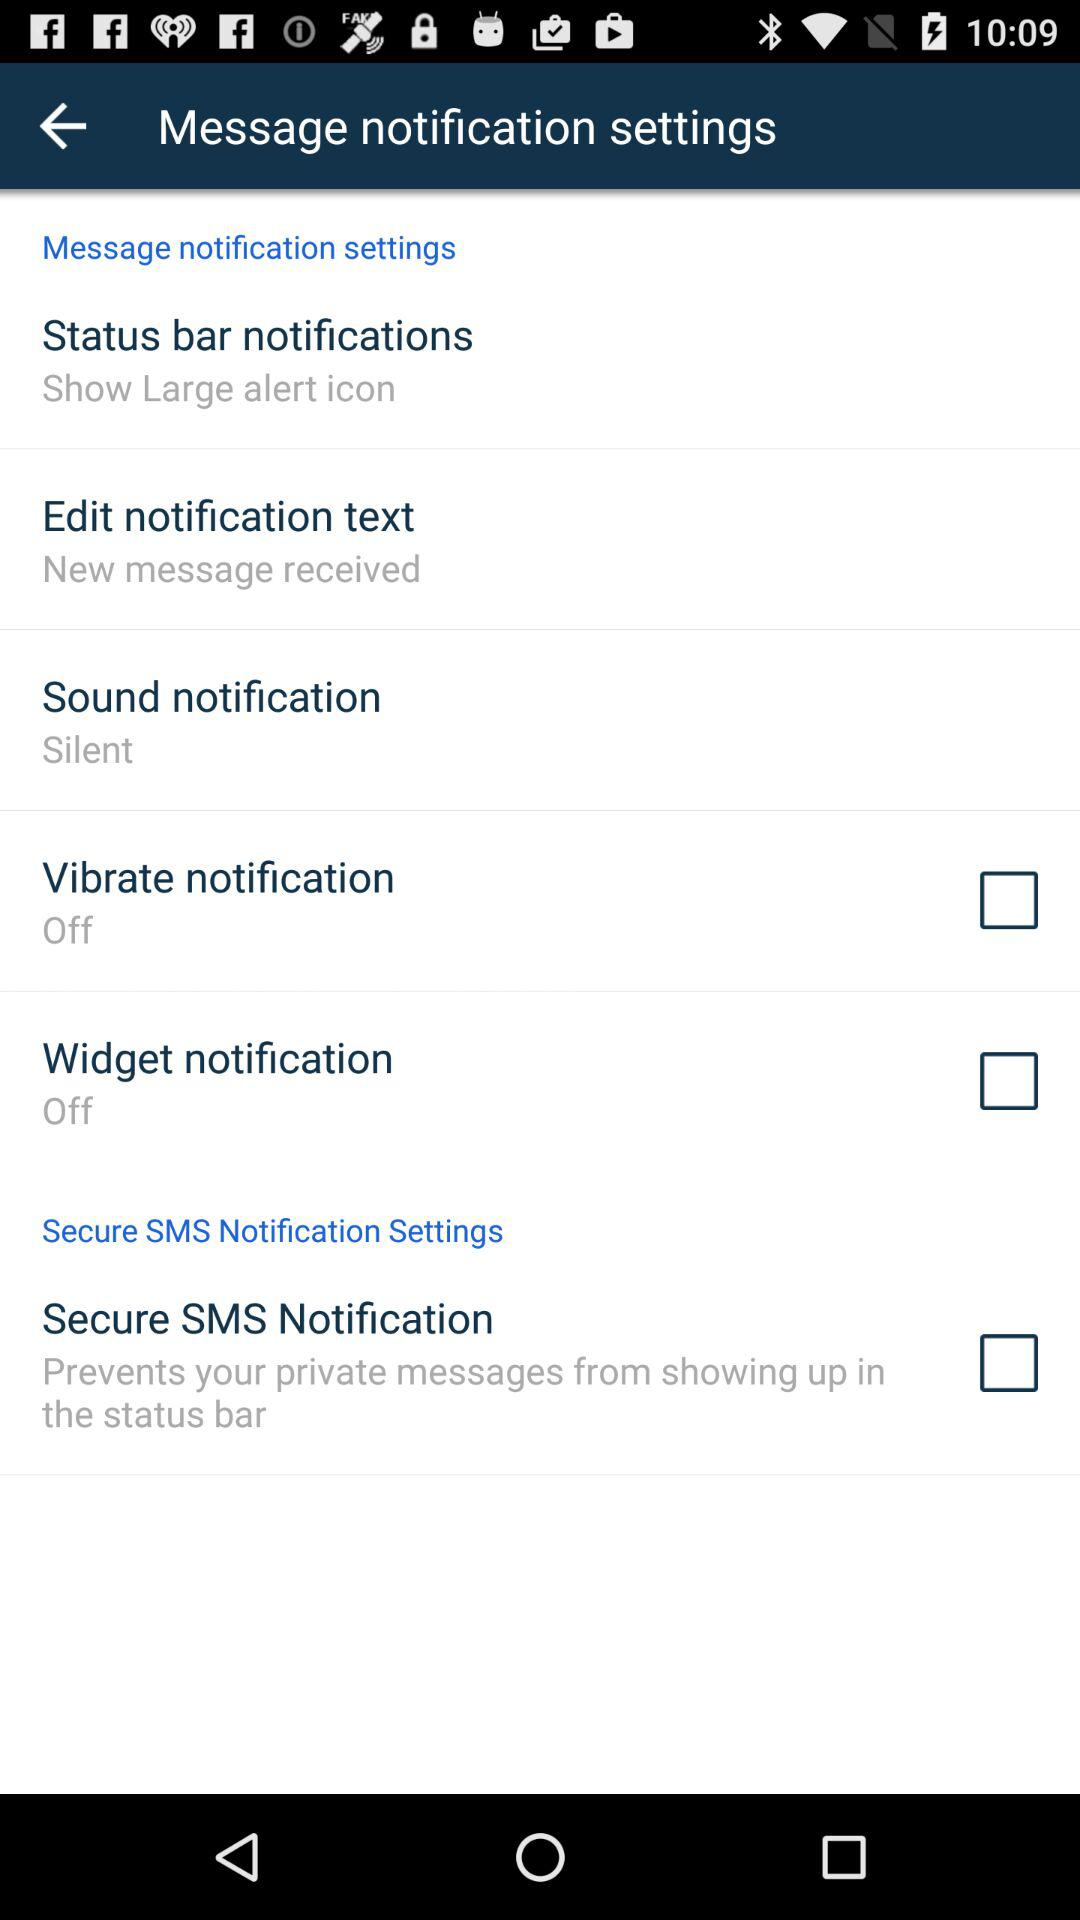How many of the notification settings are off?
Answer the question using a single word or phrase. 2 